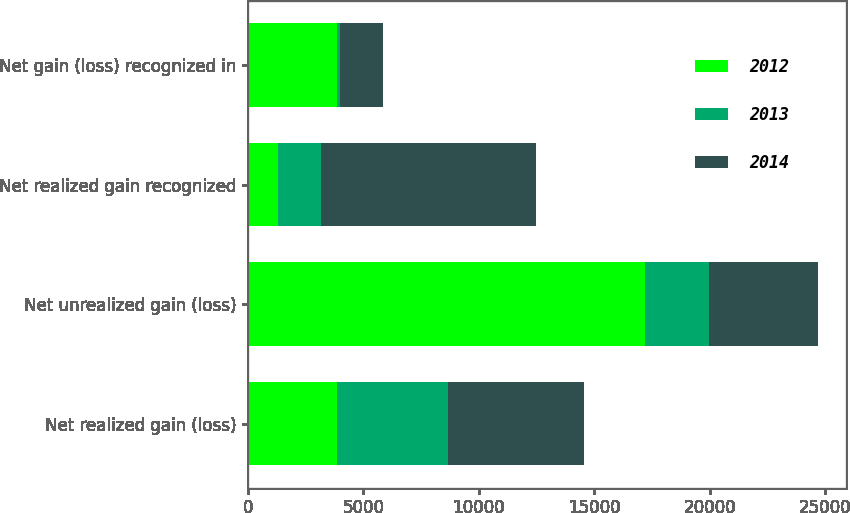<chart> <loc_0><loc_0><loc_500><loc_500><stacked_bar_chart><ecel><fcel>Net realized gain (loss)<fcel>Net unrealized gain (loss)<fcel>Net realized gain recognized<fcel>Net gain (loss) recognized in<nl><fcel>2012<fcel>3876<fcel>17217<fcel>1324<fcel>3876<nl><fcel>2013<fcel>4783<fcel>2751<fcel>1835<fcel>97<nl><fcel>2014<fcel>5899<fcel>4720<fcel>9312<fcel>1877<nl></chart> 